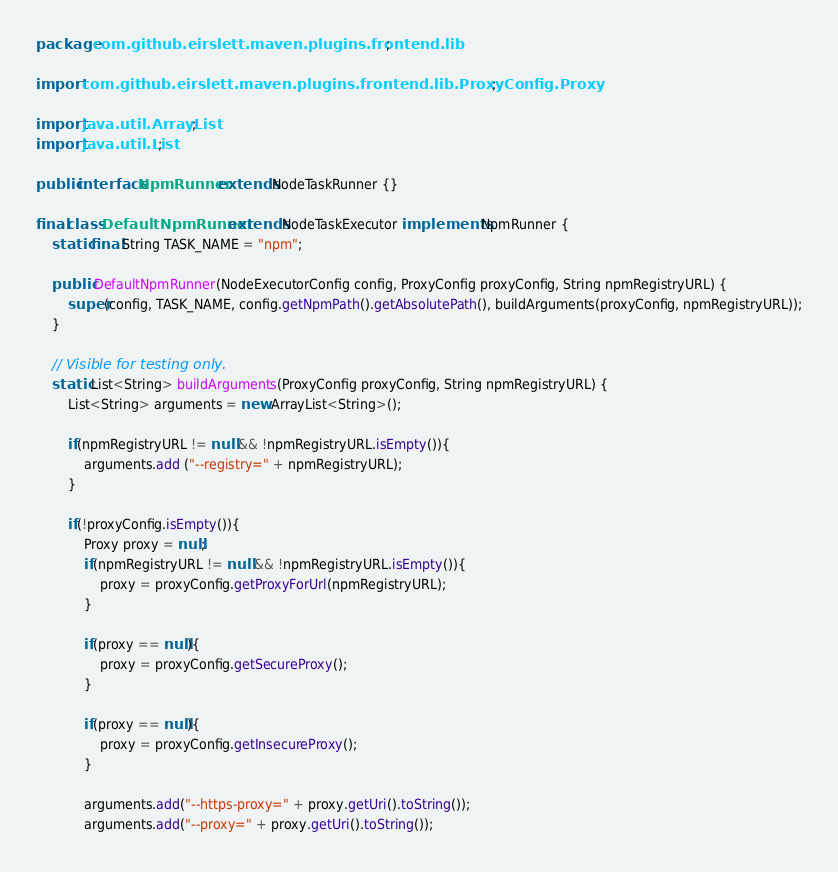<code> <loc_0><loc_0><loc_500><loc_500><_Java_>package com.github.eirslett.maven.plugins.frontend.lib;

import com.github.eirslett.maven.plugins.frontend.lib.ProxyConfig.Proxy;

import java.util.ArrayList;
import java.util.List;

public interface NpmRunner extends NodeTaskRunner {}

final class DefaultNpmRunner extends NodeTaskExecutor implements NpmRunner {
    static final String TASK_NAME = "npm";

    public DefaultNpmRunner(NodeExecutorConfig config, ProxyConfig proxyConfig, String npmRegistryURL) {
        super(config, TASK_NAME, config.getNpmPath().getAbsolutePath(), buildArguments(proxyConfig, npmRegistryURL));
    }

    // Visible for testing only.
    static List<String> buildArguments(ProxyConfig proxyConfig, String npmRegistryURL) {
        List<String> arguments = new ArrayList<String>();
               
        if(npmRegistryURL != null && !npmRegistryURL.isEmpty()){
            arguments.add ("--registry=" + npmRegistryURL);
        }

        if(!proxyConfig.isEmpty()){
            Proxy proxy = null;
            if(npmRegistryURL != null && !npmRegistryURL.isEmpty()){
                proxy = proxyConfig.getProxyForUrl(npmRegistryURL);
            }

            if(proxy == null){
                proxy = proxyConfig.getSecureProxy();
            }

            if(proxy == null){
                proxy = proxyConfig.getInsecureProxy();
            }

            arguments.add("--https-proxy=" + proxy.getUri().toString());
            arguments.add("--proxy=" + proxy.getUri().toString());
</code> 